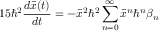Convert formula to latex. <formula><loc_0><loc_0><loc_500><loc_500>1 5 \hbar { ^ } { 2 } \frac { d \bar { x } ( t ) } { d t } = - \bar { x } ^ { 2 } \hbar { ^ } { 2 } \sum _ { n = 0 } ^ { \infty } \bar { x } ^ { n } \hbar { ^ } { n } \beta _ { n }</formula> 